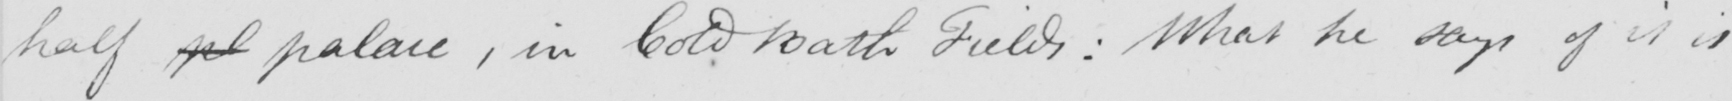Transcribe the text shown in this historical manuscript line. half pl palace , in Cold Bath Fields :  What he says of it is 